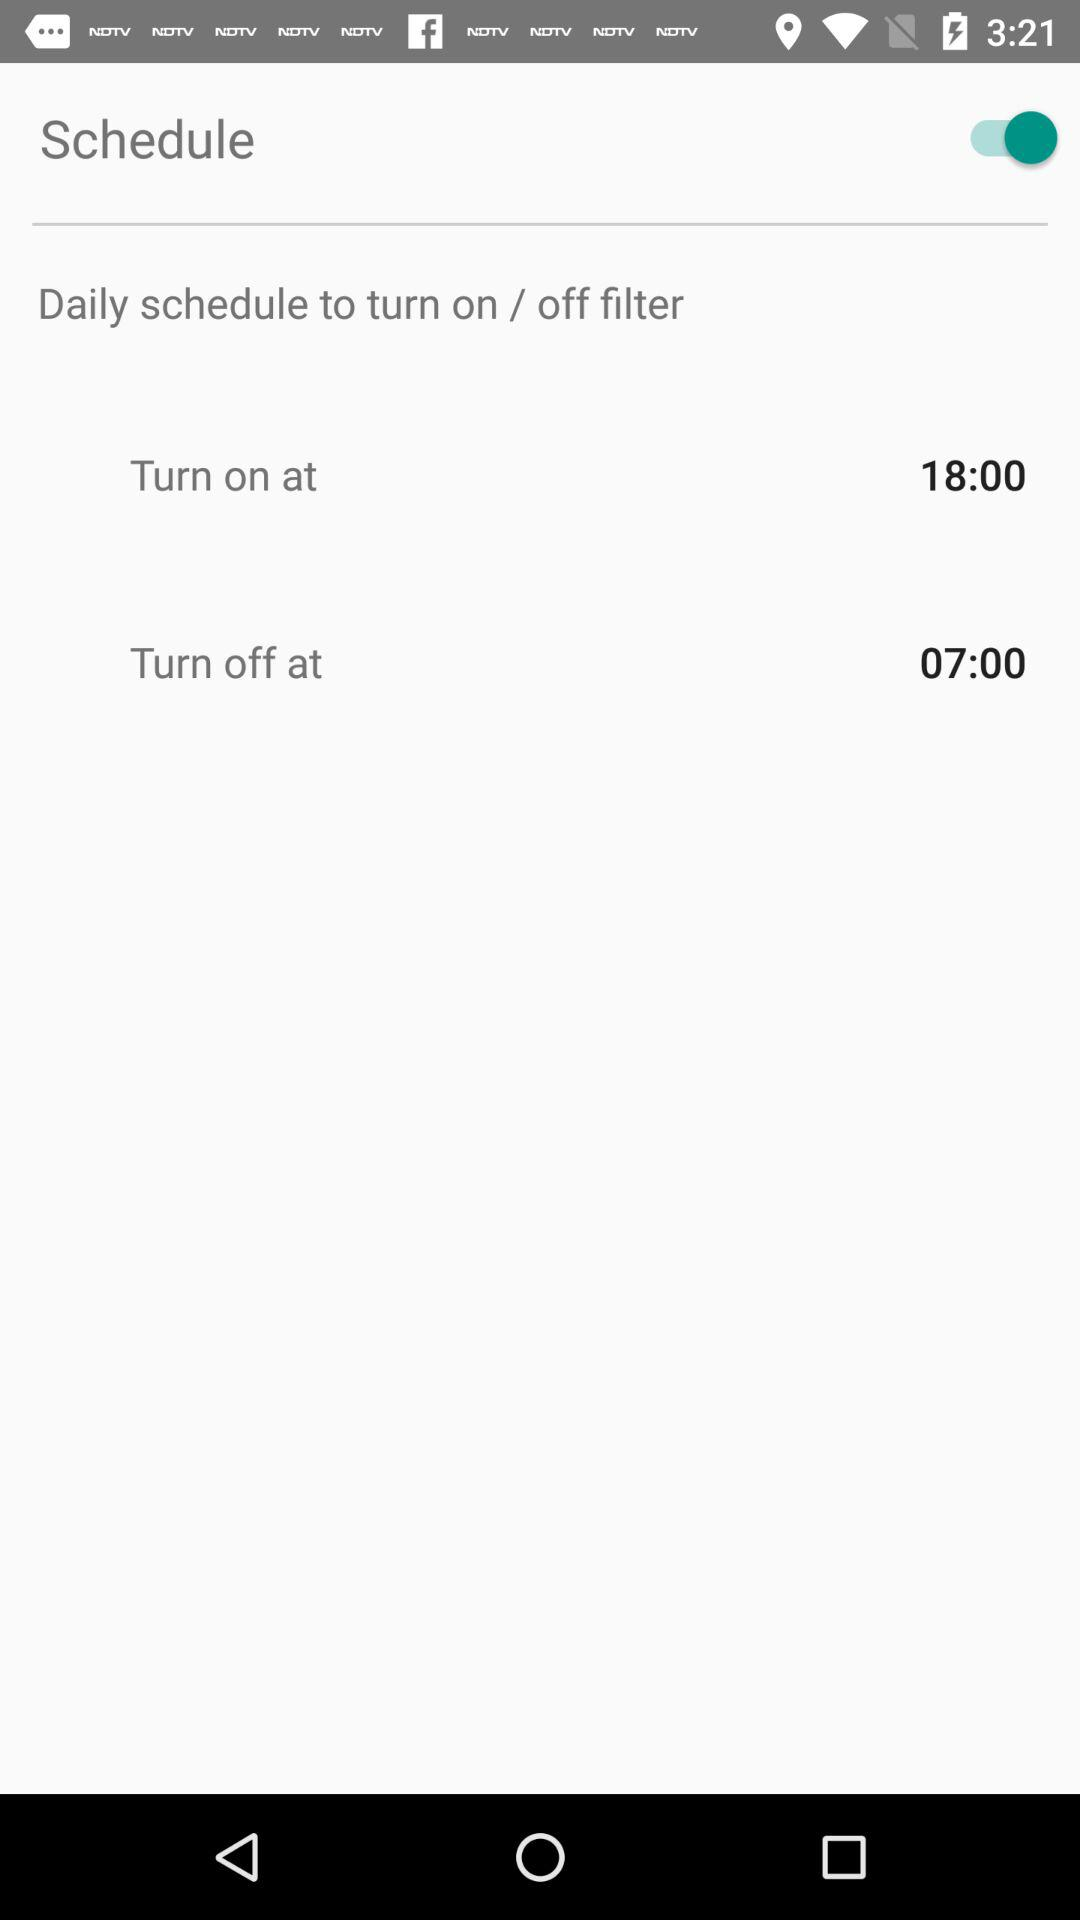What is the difference in hours between the turn on and turn off times?
Answer the question using a single word or phrase. 11 